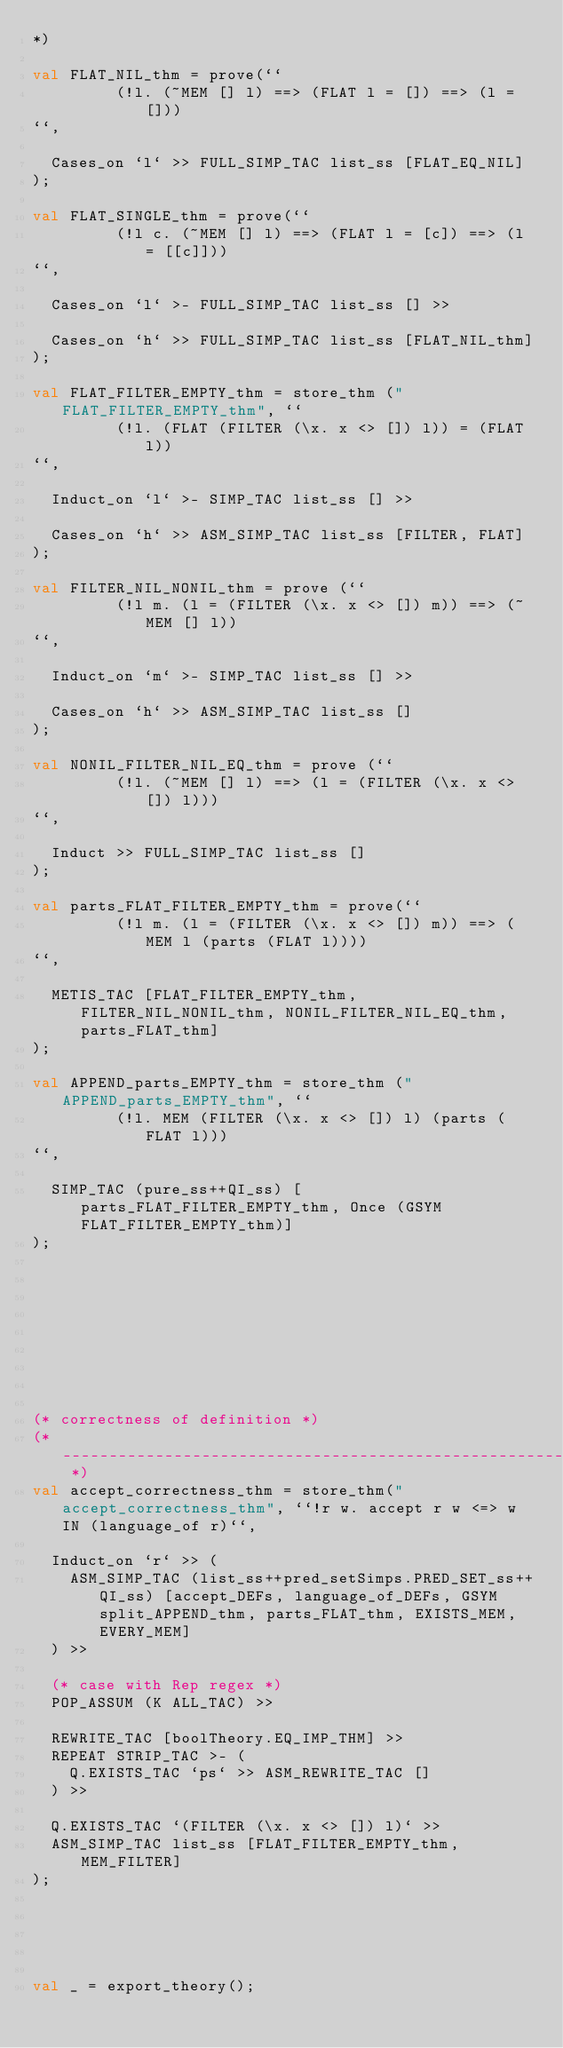Convert code to text. <code><loc_0><loc_0><loc_500><loc_500><_SML_>*)

val FLAT_NIL_thm = prove(``
         (!l. (~MEM [] l) ==> (FLAT l = []) ==> (l = []))
``,

  Cases_on `l` >> FULL_SIMP_TAC list_ss [FLAT_EQ_NIL]
);

val FLAT_SINGLE_thm = prove(``
         (!l c. (~MEM [] l) ==> (FLAT l = [c]) ==> (l = [[c]]))
``,

  Cases_on `l` >- FULL_SIMP_TAC list_ss [] >>

  Cases_on `h` >> FULL_SIMP_TAC list_ss [FLAT_NIL_thm]
);

val FLAT_FILTER_EMPTY_thm = store_thm ("FLAT_FILTER_EMPTY_thm", ``
         (!l. (FLAT (FILTER (\x. x <> []) l)) = (FLAT l))
``,

  Induct_on `l` >- SIMP_TAC list_ss [] >>

  Cases_on `h` >> ASM_SIMP_TAC list_ss [FILTER, FLAT]
);

val FILTER_NIL_NONIL_thm = prove (``
         (!l m. (l = (FILTER (\x. x <> []) m)) ==> (~MEM [] l))
``,

  Induct_on `m` >- SIMP_TAC list_ss [] >>

  Cases_on `h` >> ASM_SIMP_TAC list_ss []
);

val NONIL_FILTER_NIL_EQ_thm = prove (``
         (!l. (~MEM [] l) ==> (l = (FILTER (\x. x <> []) l)))
``,

  Induct >> FULL_SIMP_TAC list_ss []
);

val parts_FLAT_FILTER_EMPTY_thm = prove(``
         (!l m. (l = (FILTER (\x. x <> []) m)) ==> (MEM l (parts (FLAT l))))
``,

  METIS_TAC [FLAT_FILTER_EMPTY_thm, FILTER_NIL_NONIL_thm, NONIL_FILTER_NIL_EQ_thm, parts_FLAT_thm]
);

val APPEND_parts_EMPTY_thm = store_thm ("APPEND_parts_EMPTY_thm", ``
         (!l. MEM (FILTER (\x. x <> []) l) (parts (FLAT l)))
``,

  SIMP_TAC (pure_ss++QI_ss) [parts_FLAT_FILTER_EMPTY_thm, Once (GSYM FLAT_FILTER_EMPTY_thm)]
);









(* correctness of definition *)
(* ----------------------------------------------------------------------------- *)
val accept_correctness_thm = store_thm("accept_correctness_thm", ``!r w. accept r w <=> w IN (language_of r)``,

  Induct_on `r` >> (
    ASM_SIMP_TAC (list_ss++pred_setSimps.PRED_SET_ss++QI_ss) [accept_DEFs, language_of_DEFs, GSYM split_APPEND_thm, parts_FLAT_thm, EXISTS_MEM, EVERY_MEM]
  ) >>

  (* case with Rep regex *)
  POP_ASSUM (K ALL_TAC) >>

  REWRITE_TAC [boolTheory.EQ_IMP_THM] >>
  REPEAT STRIP_TAC >- (
    Q.EXISTS_TAC `ps` >> ASM_REWRITE_TAC []
  ) >>

  Q.EXISTS_TAC `(FILTER (\x. x <> []) l)` >>
  ASM_SIMP_TAC list_ss [FLAT_FILTER_EMPTY_thm, MEM_FILTER]
);





val _ = export_theory();
</code> 